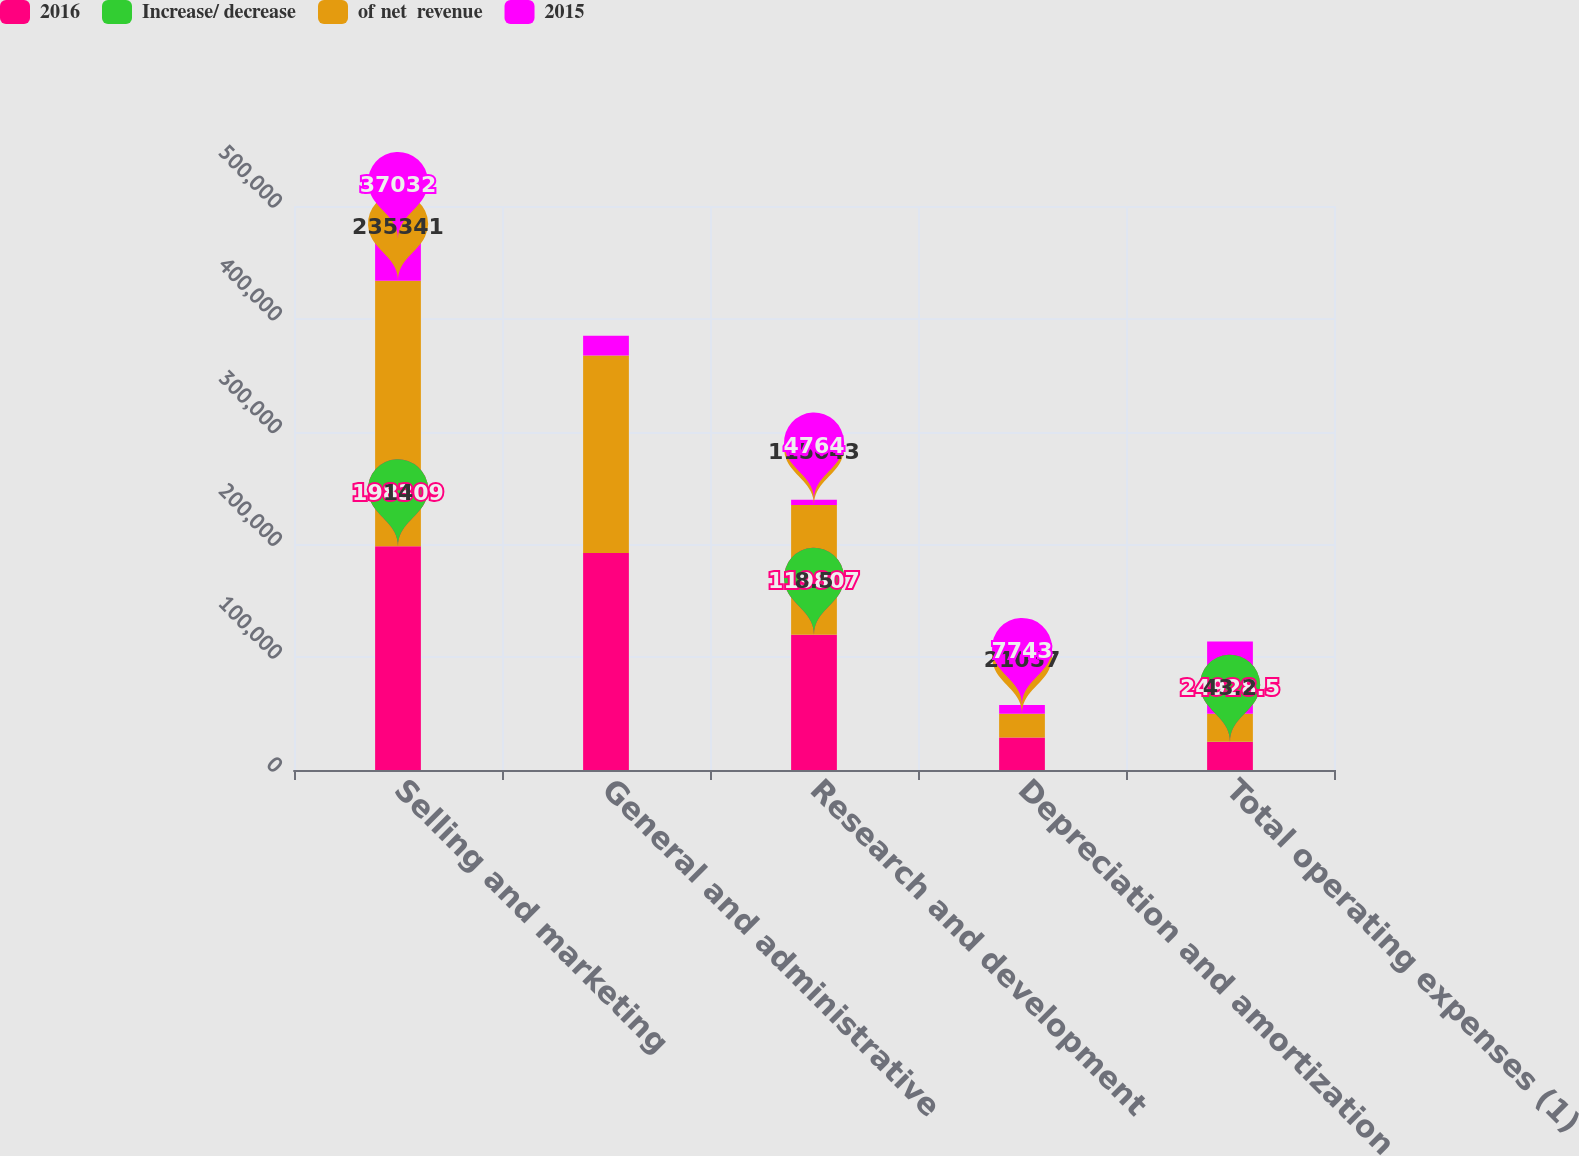Convert chart. <chart><loc_0><loc_0><loc_500><loc_500><stacked_bar_chart><ecel><fcel>Selling and marketing<fcel>General and administrative<fcel>Research and development<fcel>Depreciation and amortization<fcel>Total operating expenses (1)<nl><fcel>2016<fcel>198309<fcel>192452<fcel>119807<fcel>28800<fcel>24928.5<nl><fcel>Increase/ decrease<fcel>14<fcel>13.6<fcel>8.5<fcel>2<fcel>43.2<nl><fcel>of net  revenue<fcel>235341<fcel>175093<fcel>115043<fcel>21057<fcel>24928.5<nl><fcel>2015<fcel>37032<fcel>17359<fcel>4764<fcel>7743<fcel>64119<nl></chart> 